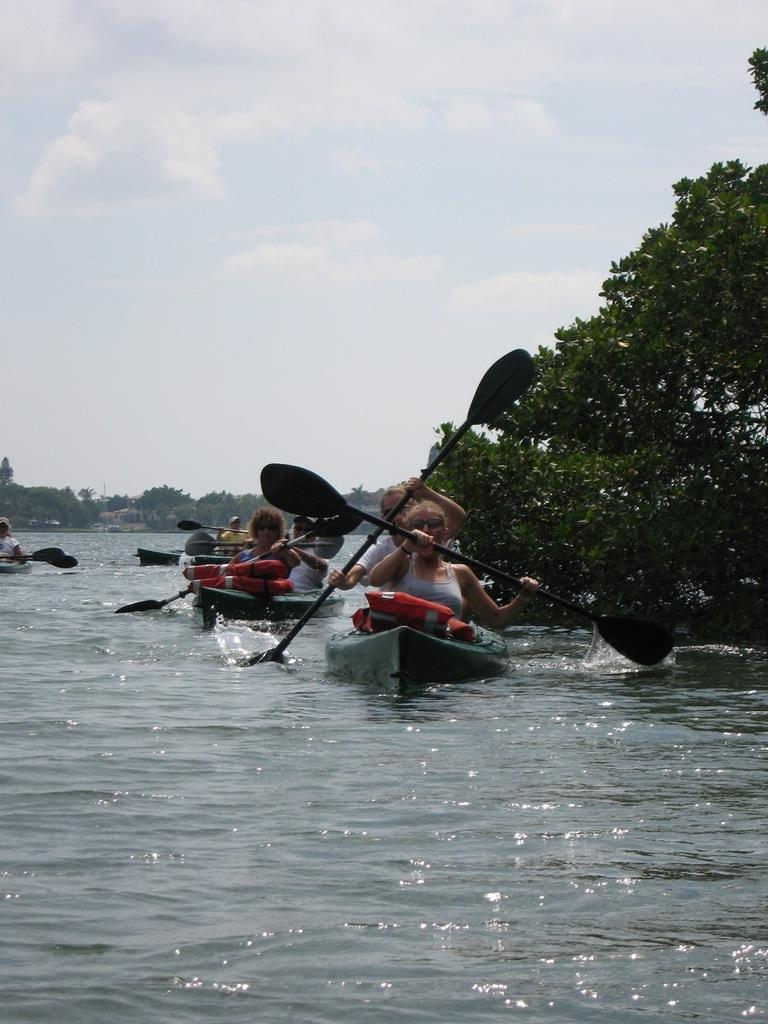What activity are the persons in the image engaged in? The persons in the image are boating. What surface are the persons boating on? The persons are on the water. What can be seen in the background of the image? There are trees and the sky visible in the background of the image. What type of heart-shaped object can be seen floating in the water in the image? There is no heart-shaped object present in the image. Can you tell me how many experts are visible in the image? There is no reference to any experts in the image. 